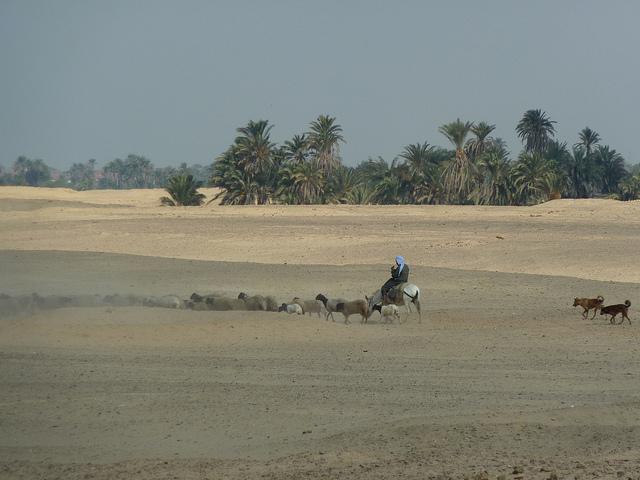What are the animals with the curly tails?
Concise answer only. Dogs. What color is the person's head covering?
Concise answer only. Blue. How many animals are attentive?
Short answer required. 2. What is in the background?
Short answer required. Trees. What is this environment?
Be succinct. Desert. What color is the goat?
Write a very short answer. Gray. Are shadows cast?
Quick response, please. No. How many types of animals are in the picture?
Short answer required. 3. How many animals are running?
Short answer required. 20. Are these animals walking on a hill?
Concise answer only. No. Where is the dog?
Concise answer only. Running beside horse. 